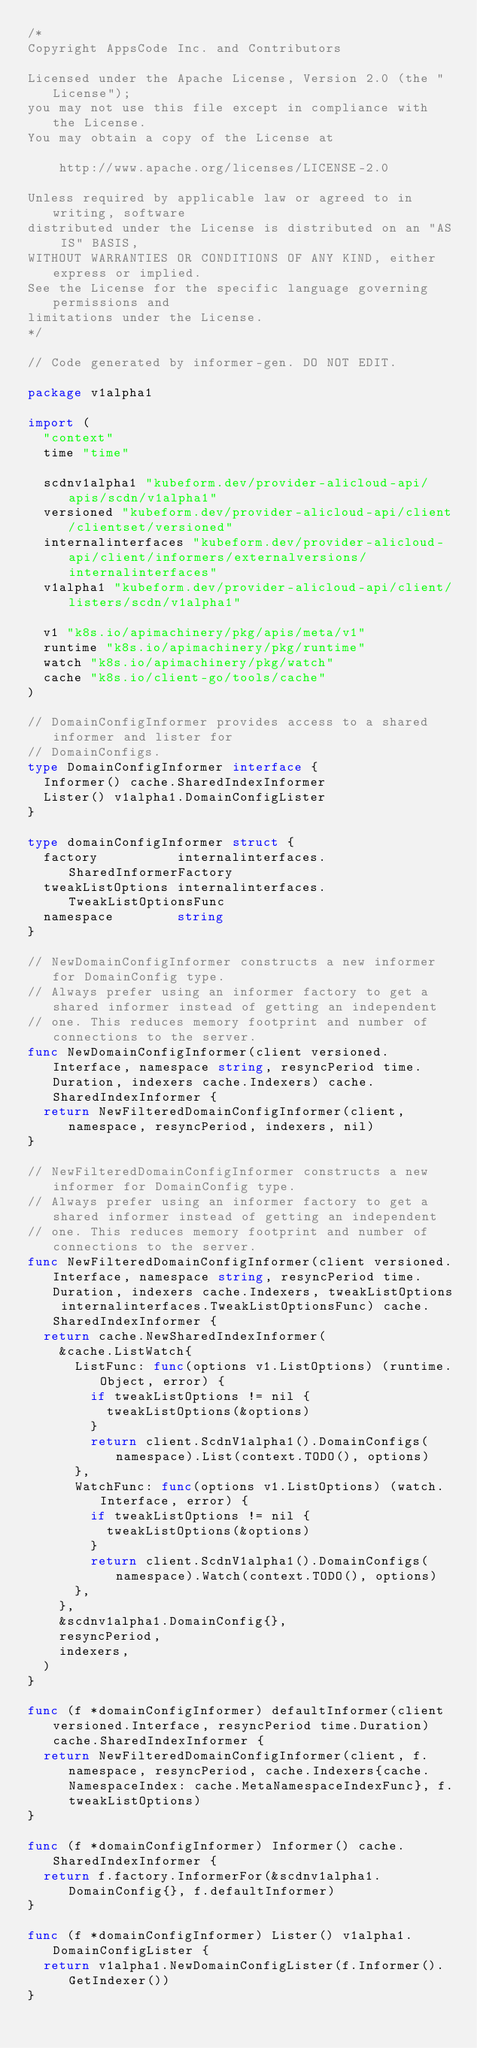Convert code to text. <code><loc_0><loc_0><loc_500><loc_500><_Go_>/*
Copyright AppsCode Inc. and Contributors

Licensed under the Apache License, Version 2.0 (the "License");
you may not use this file except in compliance with the License.
You may obtain a copy of the License at

    http://www.apache.org/licenses/LICENSE-2.0

Unless required by applicable law or agreed to in writing, software
distributed under the License is distributed on an "AS IS" BASIS,
WITHOUT WARRANTIES OR CONDITIONS OF ANY KIND, either express or implied.
See the License for the specific language governing permissions and
limitations under the License.
*/

// Code generated by informer-gen. DO NOT EDIT.

package v1alpha1

import (
	"context"
	time "time"

	scdnv1alpha1 "kubeform.dev/provider-alicloud-api/apis/scdn/v1alpha1"
	versioned "kubeform.dev/provider-alicloud-api/client/clientset/versioned"
	internalinterfaces "kubeform.dev/provider-alicloud-api/client/informers/externalversions/internalinterfaces"
	v1alpha1 "kubeform.dev/provider-alicloud-api/client/listers/scdn/v1alpha1"

	v1 "k8s.io/apimachinery/pkg/apis/meta/v1"
	runtime "k8s.io/apimachinery/pkg/runtime"
	watch "k8s.io/apimachinery/pkg/watch"
	cache "k8s.io/client-go/tools/cache"
)

// DomainConfigInformer provides access to a shared informer and lister for
// DomainConfigs.
type DomainConfigInformer interface {
	Informer() cache.SharedIndexInformer
	Lister() v1alpha1.DomainConfigLister
}

type domainConfigInformer struct {
	factory          internalinterfaces.SharedInformerFactory
	tweakListOptions internalinterfaces.TweakListOptionsFunc
	namespace        string
}

// NewDomainConfigInformer constructs a new informer for DomainConfig type.
// Always prefer using an informer factory to get a shared informer instead of getting an independent
// one. This reduces memory footprint and number of connections to the server.
func NewDomainConfigInformer(client versioned.Interface, namespace string, resyncPeriod time.Duration, indexers cache.Indexers) cache.SharedIndexInformer {
	return NewFilteredDomainConfigInformer(client, namespace, resyncPeriod, indexers, nil)
}

// NewFilteredDomainConfigInformer constructs a new informer for DomainConfig type.
// Always prefer using an informer factory to get a shared informer instead of getting an independent
// one. This reduces memory footprint and number of connections to the server.
func NewFilteredDomainConfigInformer(client versioned.Interface, namespace string, resyncPeriod time.Duration, indexers cache.Indexers, tweakListOptions internalinterfaces.TweakListOptionsFunc) cache.SharedIndexInformer {
	return cache.NewSharedIndexInformer(
		&cache.ListWatch{
			ListFunc: func(options v1.ListOptions) (runtime.Object, error) {
				if tweakListOptions != nil {
					tweakListOptions(&options)
				}
				return client.ScdnV1alpha1().DomainConfigs(namespace).List(context.TODO(), options)
			},
			WatchFunc: func(options v1.ListOptions) (watch.Interface, error) {
				if tweakListOptions != nil {
					tweakListOptions(&options)
				}
				return client.ScdnV1alpha1().DomainConfigs(namespace).Watch(context.TODO(), options)
			},
		},
		&scdnv1alpha1.DomainConfig{},
		resyncPeriod,
		indexers,
	)
}

func (f *domainConfigInformer) defaultInformer(client versioned.Interface, resyncPeriod time.Duration) cache.SharedIndexInformer {
	return NewFilteredDomainConfigInformer(client, f.namespace, resyncPeriod, cache.Indexers{cache.NamespaceIndex: cache.MetaNamespaceIndexFunc}, f.tweakListOptions)
}

func (f *domainConfigInformer) Informer() cache.SharedIndexInformer {
	return f.factory.InformerFor(&scdnv1alpha1.DomainConfig{}, f.defaultInformer)
}

func (f *domainConfigInformer) Lister() v1alpha1.DomainConfigLister {
	return v1alpha1.NewDomainConfigLister(f.Informer().GetIndexer())
}
</code> 